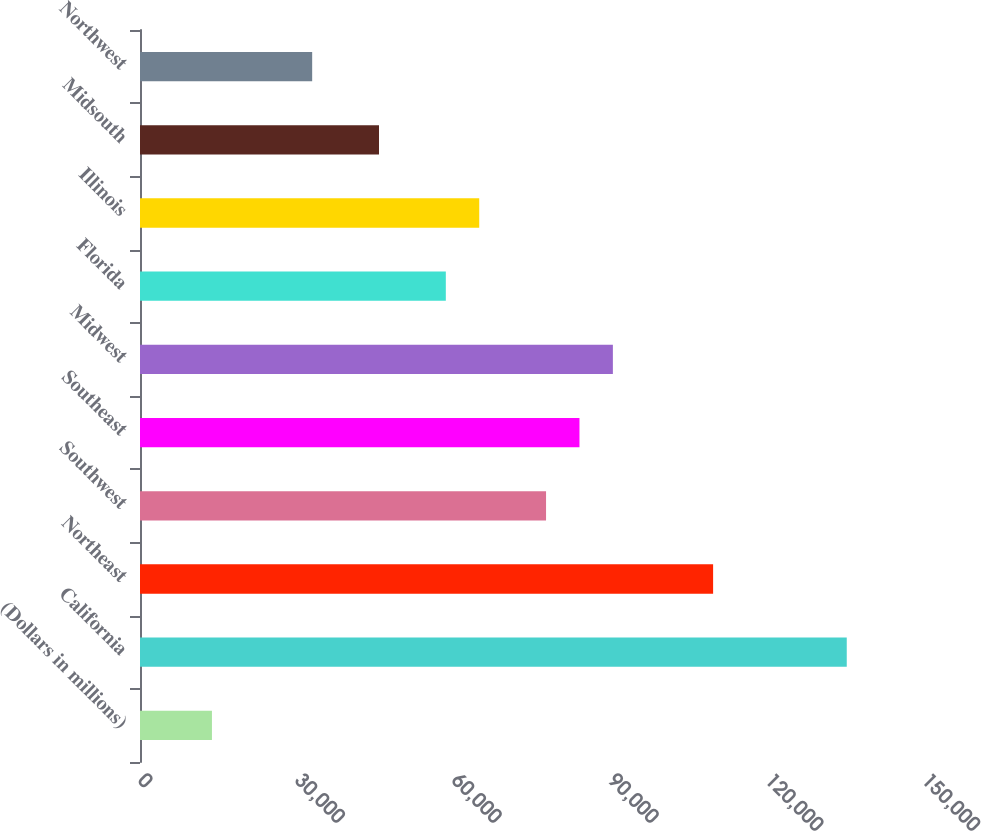<chart> <loc_0><loc_0><loc_500><loc_500><bar_chart><fcel>(Dollars in millions)<fcel>California<fcel>Northeast<fcel>Southwest<fcel>Southeast<fcel>Midwest<fcel>Florida<fcel>Illinois<fcel>Midsouth<fcel>Northwest<nl><fcel>13764<fcel>135222<fcel>109652<fcel>77689<fcel>84081.5<fcel>90474<fcel>58511.5<fcel>64904<fcel>45726.5<fcel>32941.5<nl></chart> 